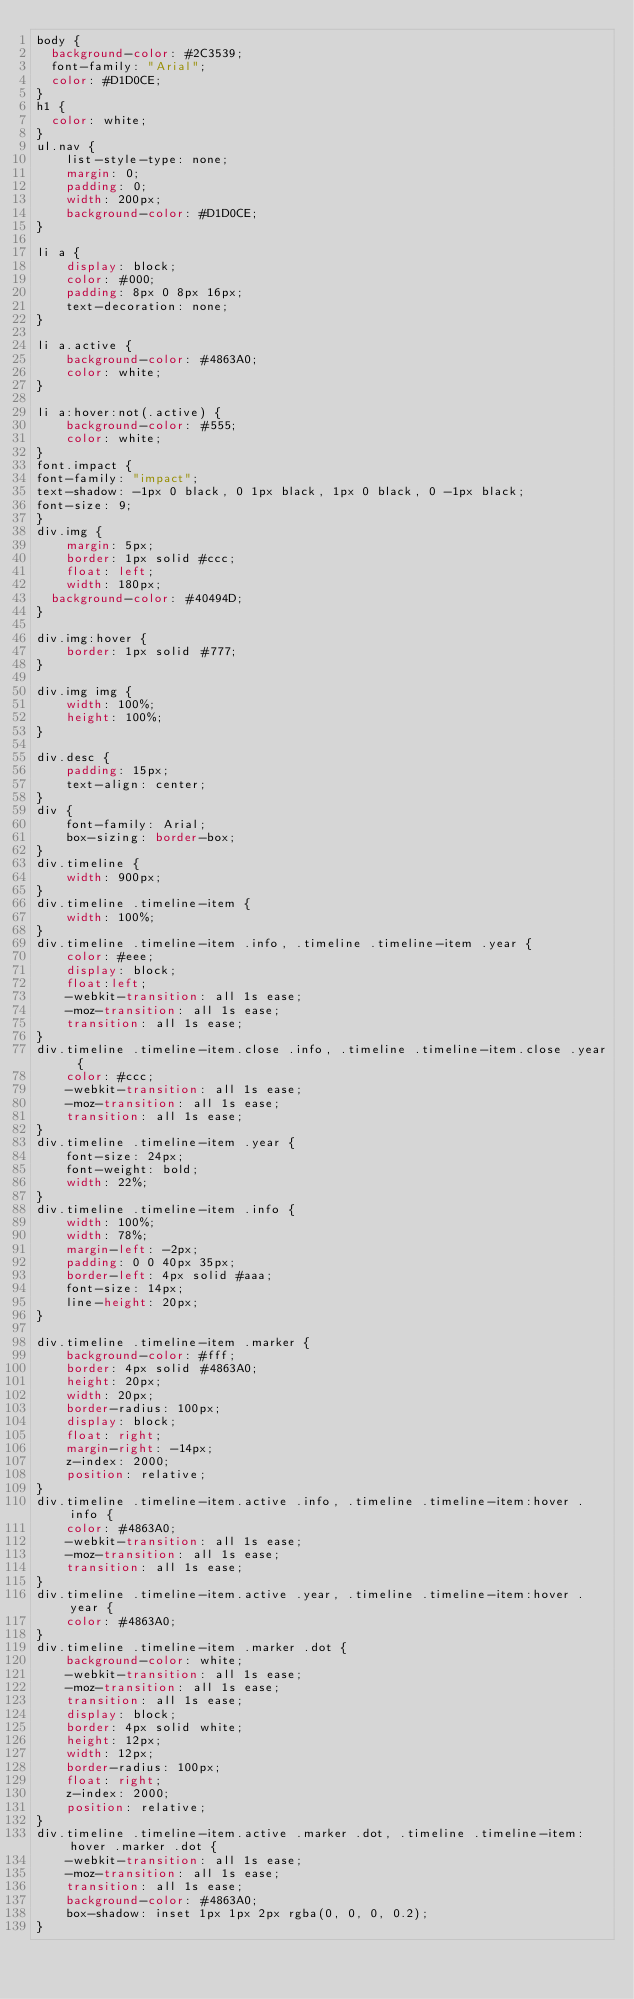<code> <loc_0><loc_0><loc_500><loc_500><_CSS_>body {
	background-color: #2C3539;
	font-family: "Arial";
	color: #D1D0CE;
}
h1 {
	color: white;
}
ul.nav {
    list-style-type: none;
    margin: 0;
    padding: 0;
    width: 200px;
    background-color: #D1D0CE;
}

li a {
    display: block;
    color: #000;
    padding: 8px 0 8px 16px;
    text-decoration: none;
}

li a.active {
    background-color: #4863A0;
    color: white;
}

li a:hover:not(.active) {
    background-color: #555;
    color: white;
}
font.impact {
font-family: "impact";
text-shadow: -1px 0 black, 0 1px black, 1px 0 black, 0 -1px black;
font-size: 9;
}
div.img {
    margin: 5px;
    border: 1px solid #ccc;
    float: left;
    width: 180px;
	background-color: #40494D;
}	

div.img:hover {
    border: 1px solid #777;
}

div.img img {
    width: 100%;
    height: 100%;
}

div.desc {
    padding: 15px;
    text-align: center;
}
div {
    font-family: Arial;
    box-sizing: border-box;
}
div.timeline {
    width: 900px;
}
div.timeline .timeline-item {
    width: 100%;
}
div.timeline .timeline-item .info, .timeline .timeline-item .year {
    color: #eee;
    display: block;
    float:left;
    -webkit-transition: all 1s ease;
    -moz-transition: all 1s ease;
    transition: all 1s ease;
}
div.timeline .timeline-item.close .info, .timeline .timeline-item.close .year {
    color: #ccc;
    -webkit-transition: all 1s ease;
    -moz-transition: all 1s ease;
    transition: all 1s ease;
}
div.timeline .timeline-item .year {
    font-size: 24px;
    font-weight: bold;
    width: 22%;
}
div.timeline .timeline-item .info {
    width: 100%;
    width: 78%;
    margin-left: -2px;
    padding: 0 0 40px 35px;
    border-left: 4px solid #aaa;
    font-size: 14px;
    line-height: 20px;
}

div.timeline .timeline-item .marker {
    background-color: #fff;
    border: 4px solid #4863A0;
    height: 20px;
    width: 20px;
    border-radius: 100px;
    display: block;
    float: right;
    margin-right: -14px;
    z-index: 2000;
    position: relative;
}
div.timeline .timeline-item.active .info, .timeline .timeline-item:hover .info {
    color: #4863A0;
    -webkit-transition: all 1s ease;
    -moz-transition: all 1s ease;
    transition: all 1s ease;
}
div.timeline .timeline-item.active .year, .timeline .timeline-item:hover .year {
    color: #4863A0;
}
div.timeline .timeline-item .marker .dot {
    background-color: white;
    -webkit-transition: all 1s ease;
    -moz-transition: all 1s ease;
    transition: all 1s ease;
    display: block;
    border: 4px solid white;
    height: 12px;
    width: 12px;
    border-radius: 100px;
    float: right;
    z-index: 2000;
    position: relative;
}
div.timeline .timeline-item.active .marker .dot, .timeline .timeline-item:hover .marker .dot {
    -webkit-transition: all 1s ease;
    -moz-transition: all 1s ease;
    transition: all 1s ease;
    background-color: #4863A0;
    box-shadow: inset 1px 1px 2px rgba(0, 0, 0, 0.2);
}</code> 